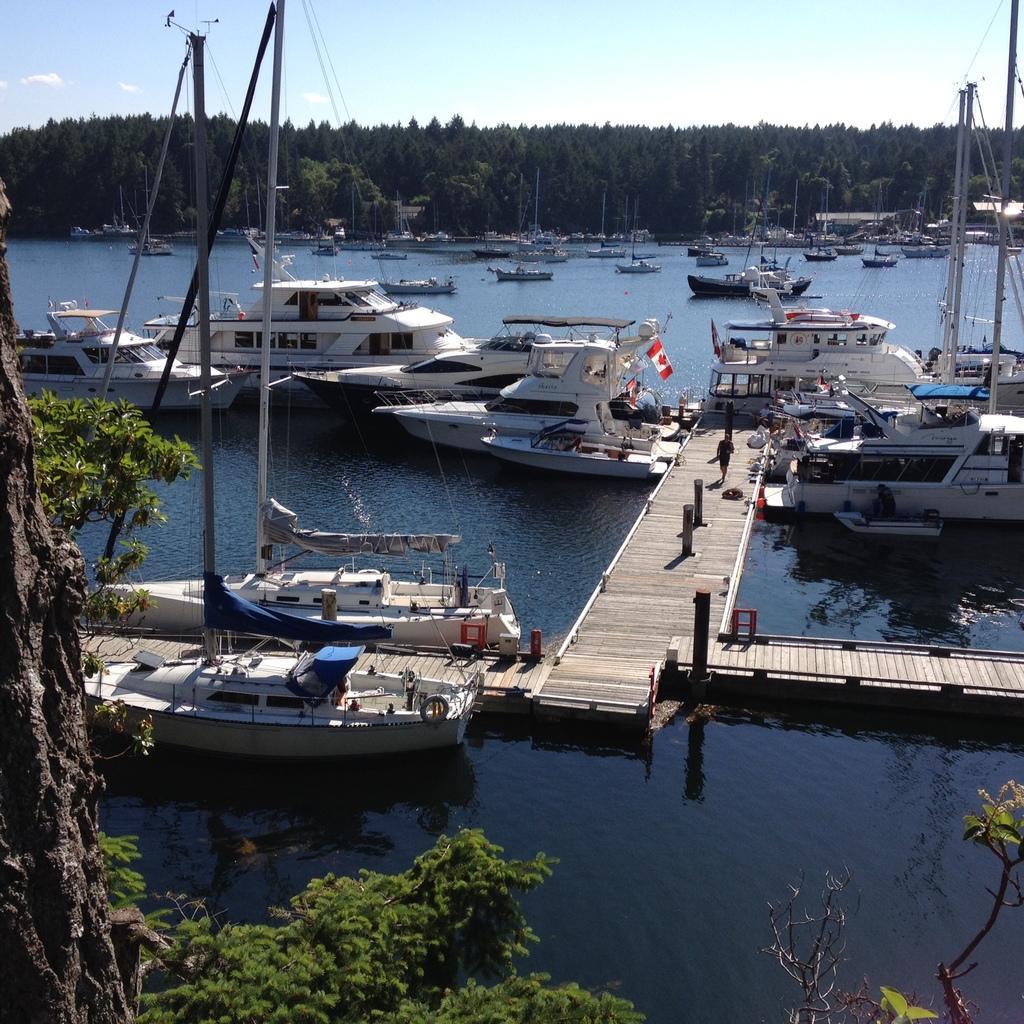How would you summarize this image in a sentence or two? In this image we can see boats, ships are on water, there is wooden walkway on which there are some persons walking through it and in the background of the image there are some trees and clear sky. 